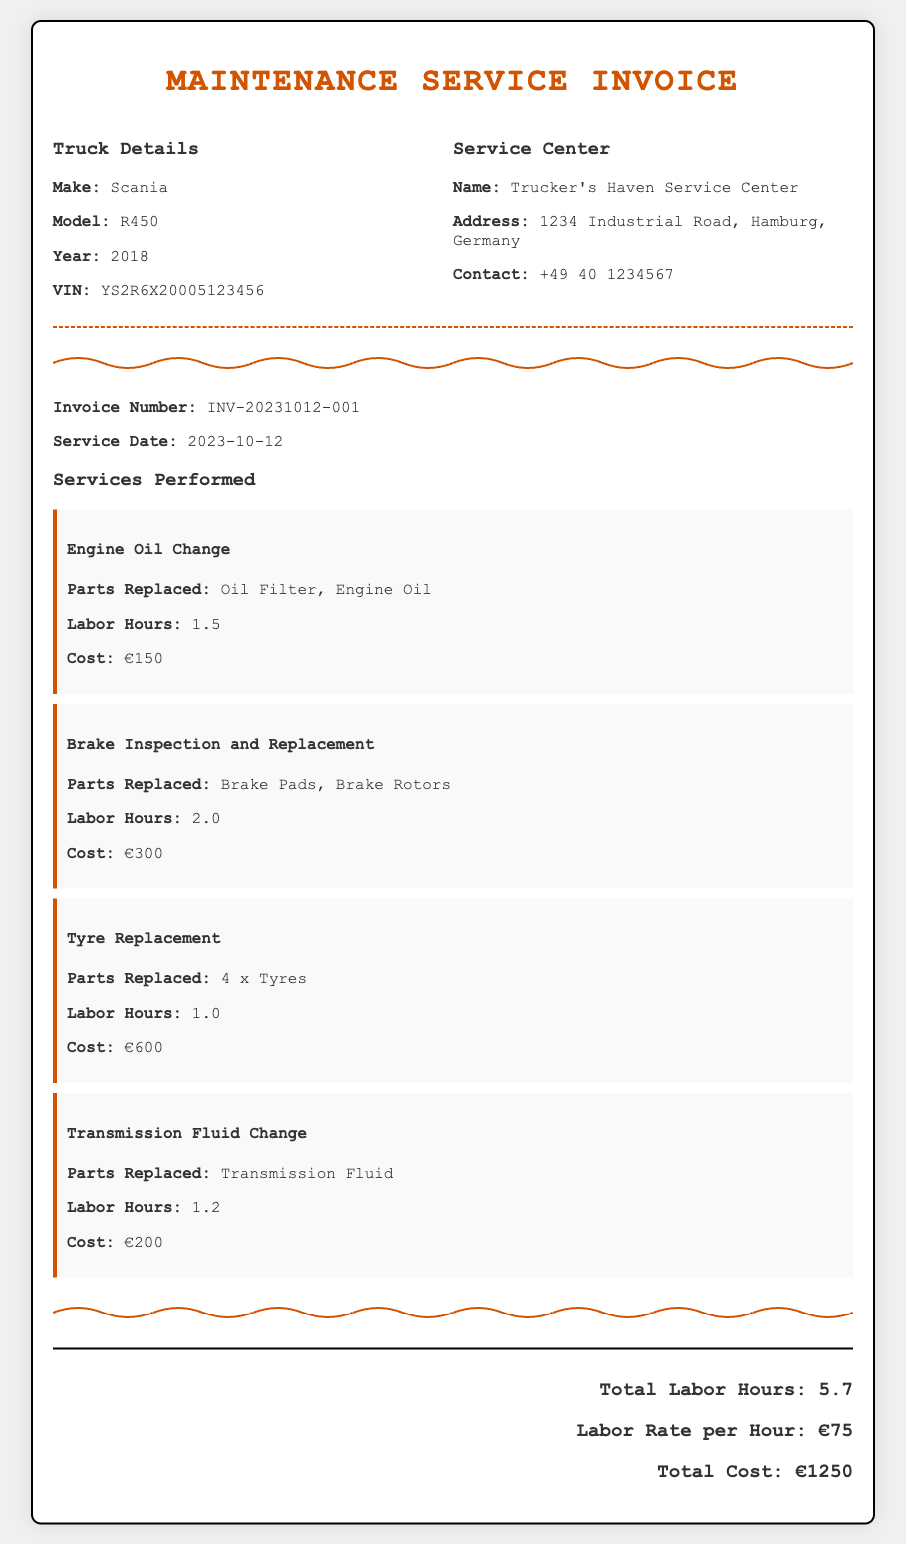what is the make of the truck? The make of the truck is specified in the document under the Truck Details section.
Answer: Scania what is the model of the truck? The model of the truck can be found in the Truck Details section of the document.
Answer: R450 what is the year of the truck? The year of the truck is listed in the Truck Details section.
Answer: 2018 who performed the maintenance service? The service center performing the maintenance is mentioned in the Service Center section of the document.
Answer: Trucker's Haven Service Center what is the total cost of the service? The total cost is clearly outlined in the total section of the document.
Answer: €1250 how many labor hours were recorded? The total labor hours can be found in the total section at the bottom of the document.
Answer: 5.7 what is the service date of the invoice? The service date is mentioned in the invoice details section of the document.
Answer: 2023-10-12 how many parts were replaced during the Tyre Replacement service? The number of parts replaced can be found in the service list under Tyre Replacement.
Answer: 4 x Tyres how much was charged for the Brake Inspection and Replacement? The charge for Brake Inspection and Replacement is listed in the service item description.
Answer: €300 